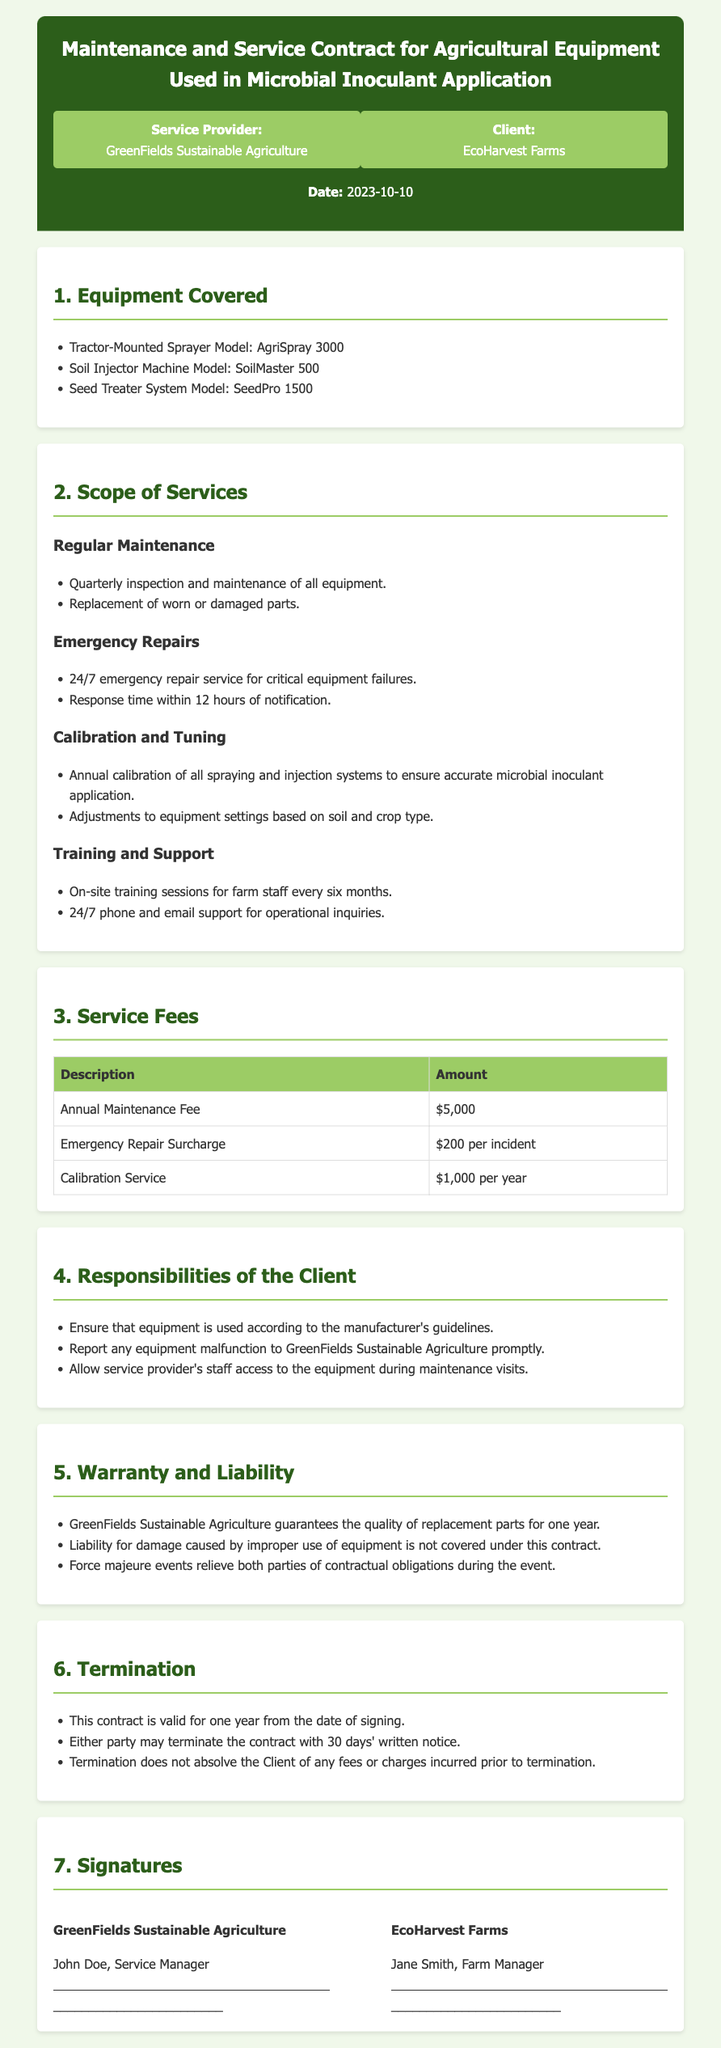What is the name of the service provider? The service provider is identified in the document as "GreenFields Sustainable Agriculture".
Answer: GreenFields Sustainable Agriculture What is the date of the contract? The date specified in the document is the signing date of the contract, which is "2023-10-10".
Answer: 2023-10-10 How often is regular maintenance scheduled? The document specifies that regular maintenance is to be conducted "Quarterly".
Answer: Quarterly What is the annual maintenance fee? The fee listed in the document for annual maintenance is "$5,000".
Answer: $5,000 What is the response time for emergency repairs? It states that the response time for emergency repairs is "within 12 hours" of notification.
Answer: within 12 hours How long is the contract valid? The document explicitly states that the contract is valid for "one year" from the date of signing.
Answer: one year What is the penalty for improper use of equipment? The document mentions that liability for damage caused by “improper use” is "not covered" under this contract.
Answer: not covered How many on-site training sessions are included per year? The document states that there will be "two" on-site training sessions per year, held every six months.
Answer: two What must the client do if equipment malfunctions? It is required that the client "report any equipment malfunction" to the service provider.
Answer: report any equipment malfunction 